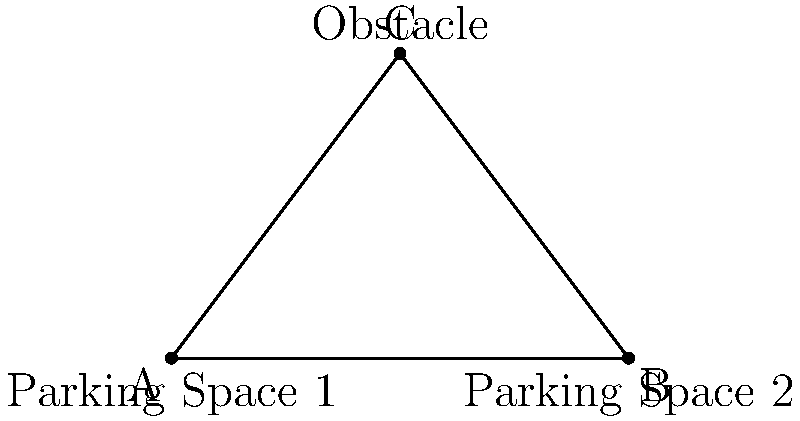You're helping a friend find the shortest path between two parking spaces in a crowded lot. The spaces are located at points A and B, which are 6 units apart. There's an obstacle at point C, forming an isosceles triangle ABC with AC = BC = 5 units. What is the shortest distance to walk from A to B while avoiding the obstacle? Let's approach this step-by-step:

1) We have an isosceles triangle ABC where AC = BC = 5 units, and AB = 6 units.

2) The shortest path will either be:
   a) Straight from A to B (if the obstacle doesn't interfere)
   b) From A to C to B (if the obstacle blocks the direct path)

3) To determine which path is shorter, we need to calculate the height of the triangle (the perpendicular distance from C to AB).

4) We can use the Pythagorean theorem in the right triangle formed by this height:

   $$(3)^2 + h^2 = 5^2$$

5) Solving for h:
   $$h^2 = 5^2 - 3^2 = 25 - 9 = 16$$
   $$h = 4$$

6) Since the height (4 units) is less than AC or BC (5 units), the obstacle does interfere with the direct path.

7) Therefore, the shortest path is A to C to B.

8) The total length of this path is:
   $$AC + BC = 5 + 5 = 10$$ units

Thus, the shortest distance to walk from A to B while avoiding the obstacle is 10 units.
Answer: 10 units 